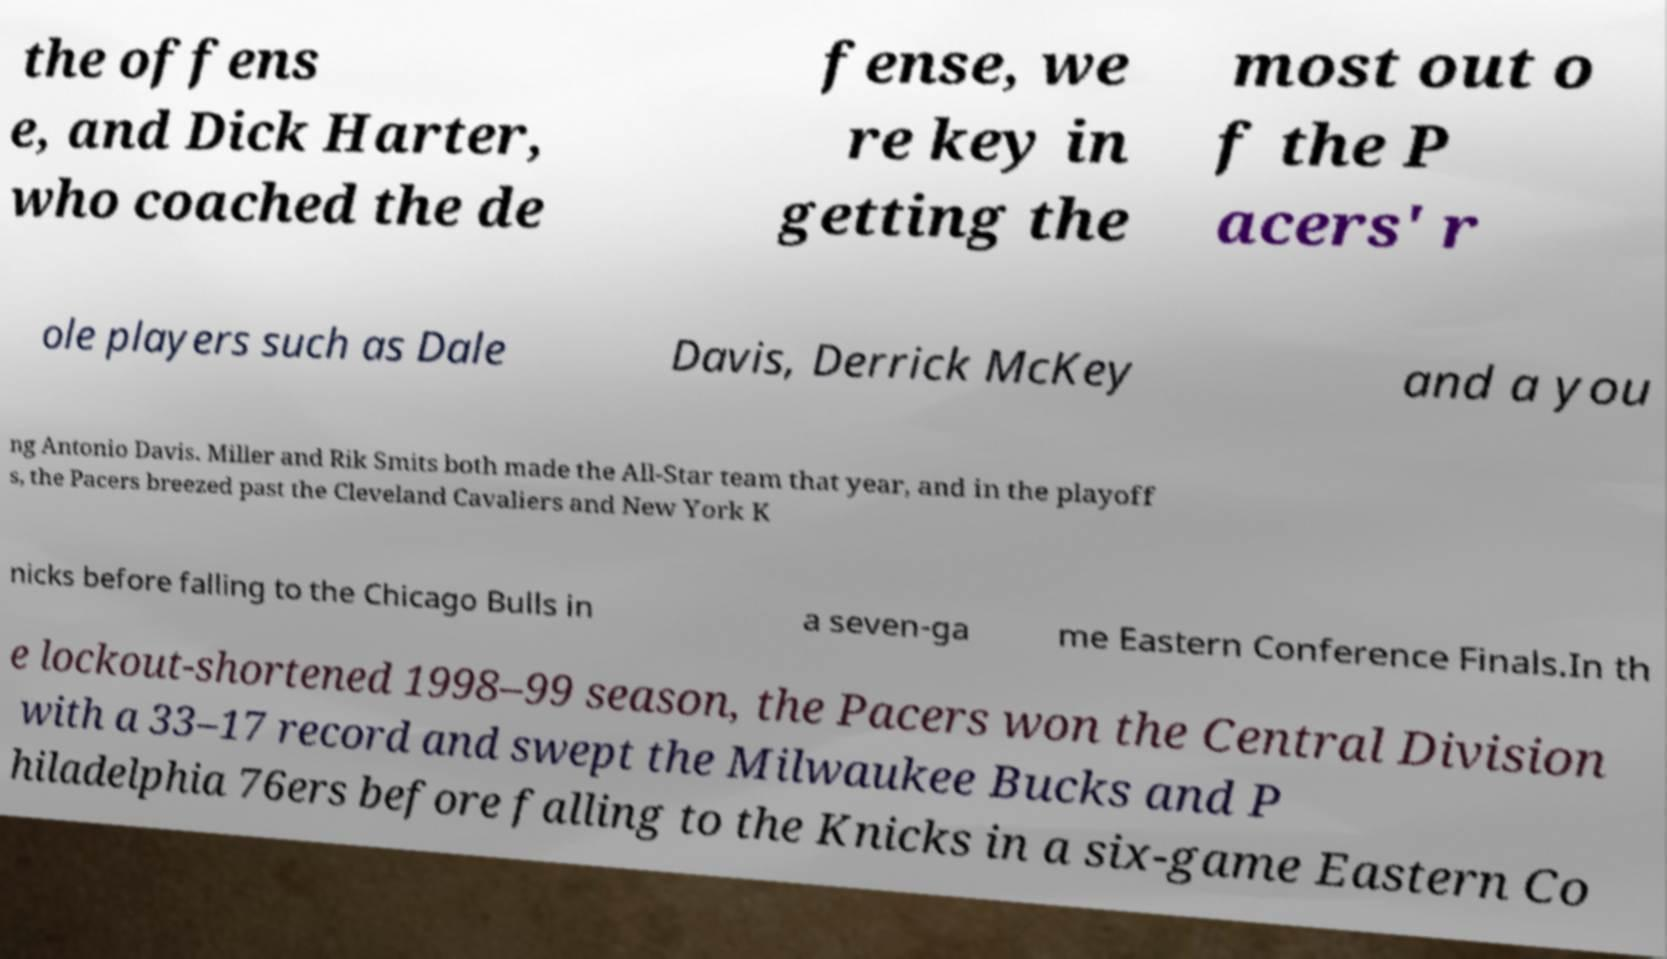What messages or text are displayed in this image? I need them in a readable, typed format. the offens e, and Dick Harter, who coached the de fense, we re key in getting the most out o f the P acers' r ole players such as Dale Davis, Derrick McKey and a you ng Antonio Davis. Miller and Rik Smits both made the All-Star team that year, and in the playoff s, the Pacers breezed past the Cleveland Cavaliers and New York K nicks before falling to the Chicago Bulls in a seven-ga me Eastern Conference Finals.In th e lockout-shortened 1998–99 season, the Pacers won the Central Division with a 33–17 record and swept the Milwaukee Bucks and P hiladelphia 76ers before falling to the Knicks in a six-game Eastern Co 